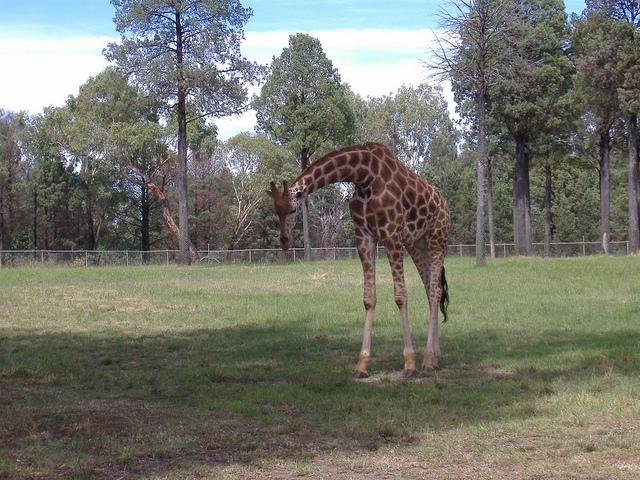Is the giraffe in a park?
Concise answer only. Yes. What is the giraffe doing?
Write a very short answer. Looking down. Is the giraffe sad?
Give a very brief answer. No. 